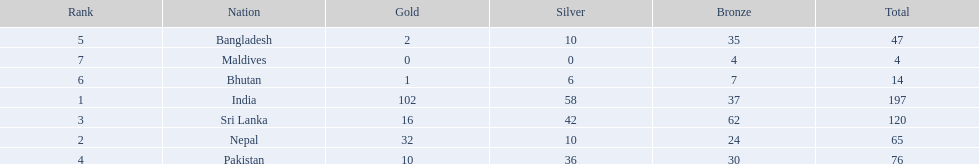What are all the countries listed in the table? India, Nepal, Sri Lanka, Pakistan, Bangladesh, Bhutan, Maldives. Which of these is not india? Nepal, Sri Lanka, Pakistan, Bangladesh, Bhutan, Maldives. Of these, which is first? Nepal. 